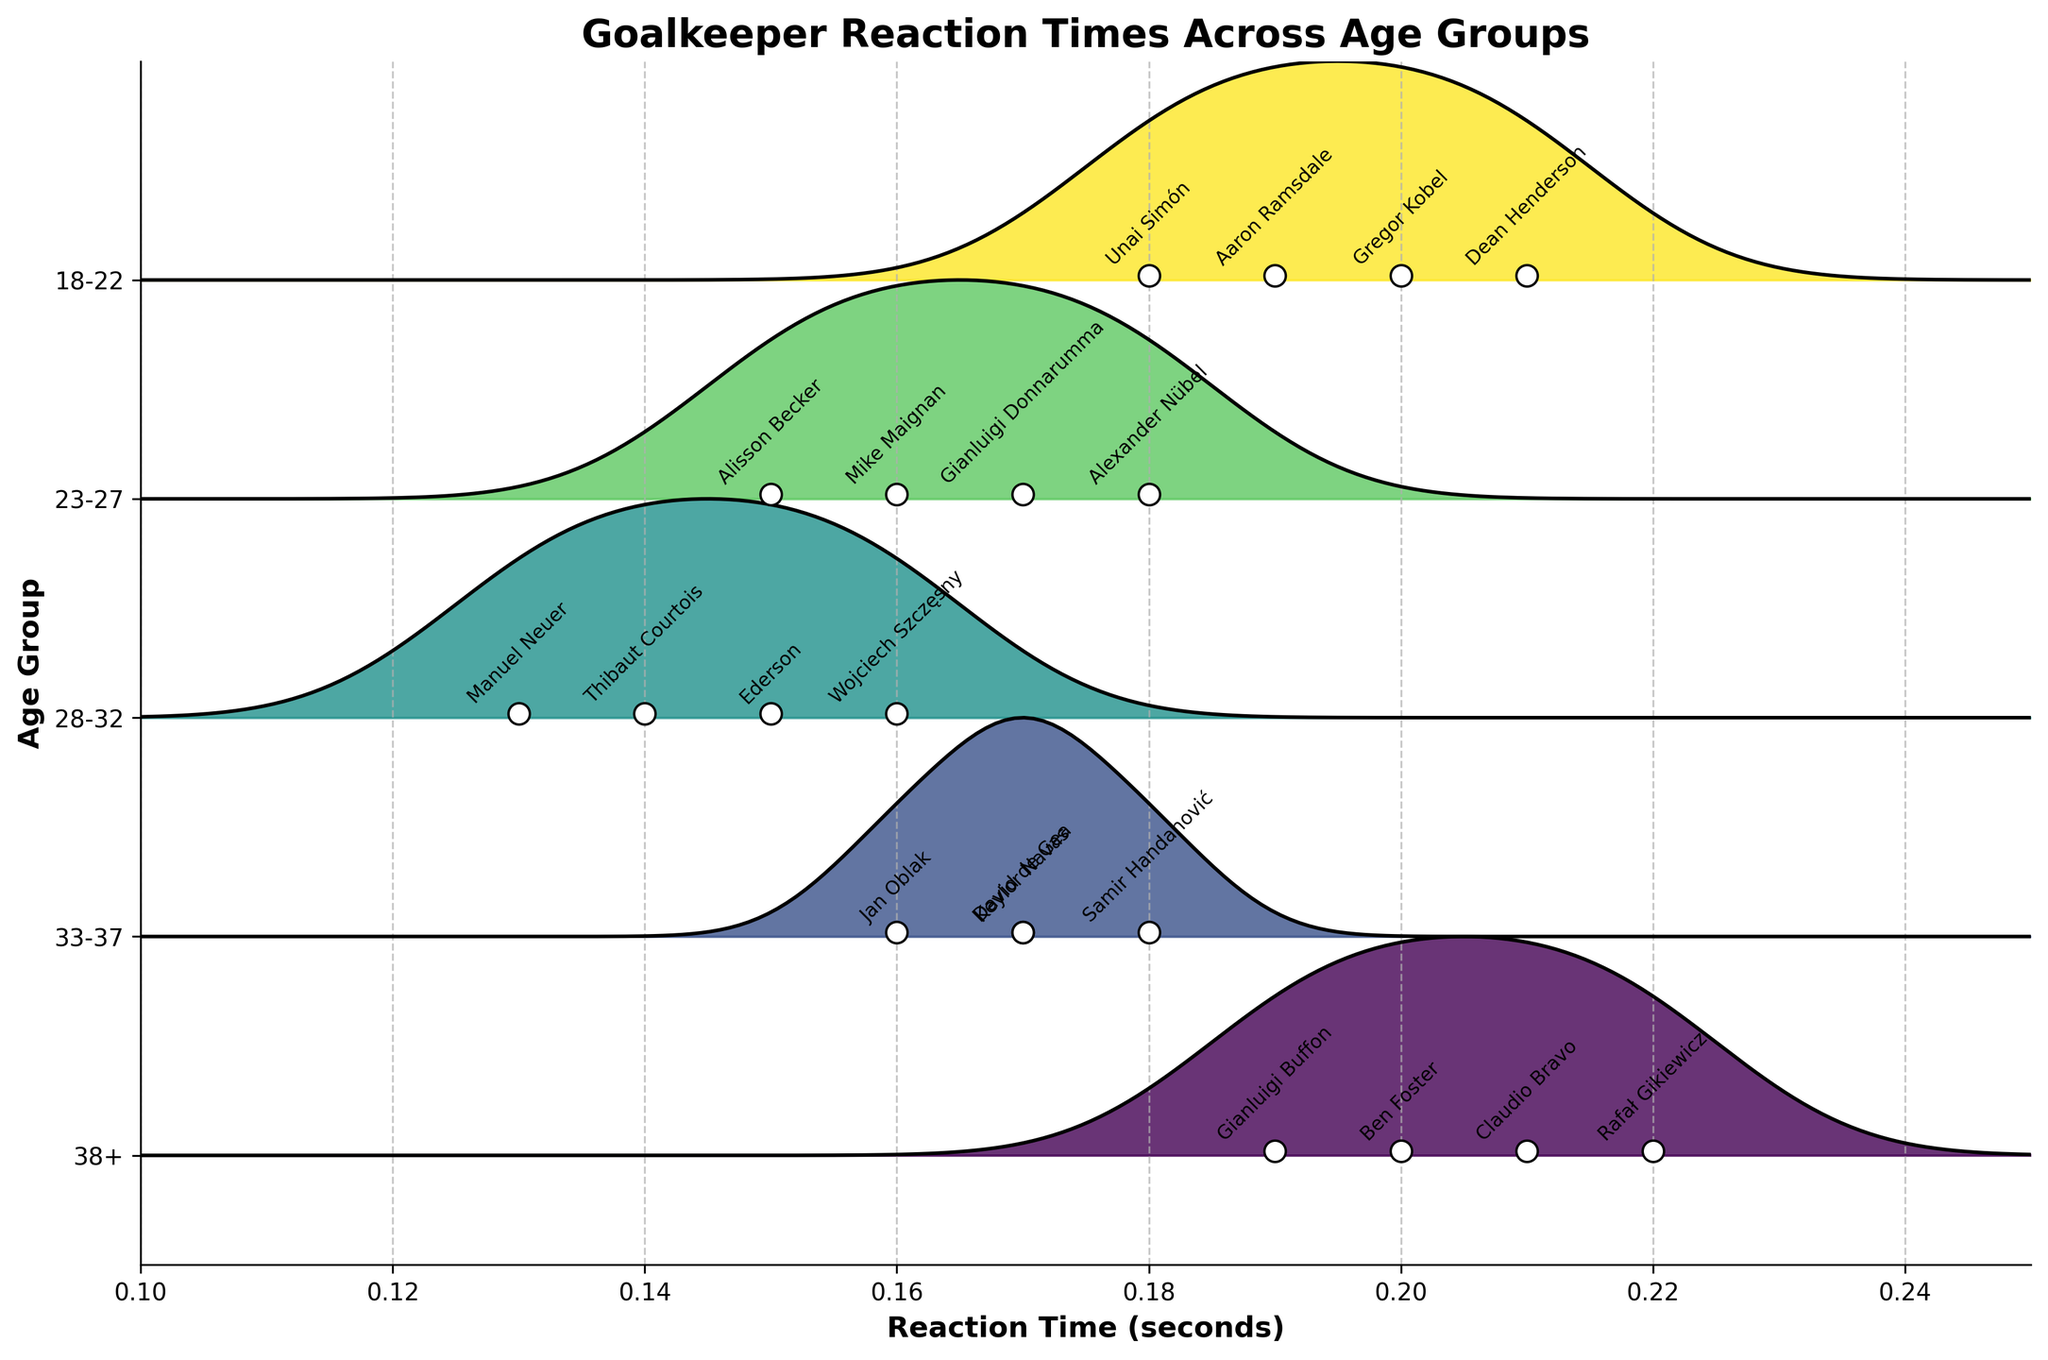What is the title of the plot? The title is prominently displayed at the top of the figure, summarizing the main context of the visualization.
Answer: Goalkeeper Reaction Times Across Age Groups Which age group has the best (lowest) average reaction time? By looking at the peaks of the ridgeline plots, the age group with the lowest position on the x-axis represents the best average reaction time.
Answer: 28-32 What are the reaction times of goalkeepers in the 38+ age group? The reaction times for the goalkeepers in this age group can be identified by the scatter points along the ridgeline plot.
Answer: 0.19, 0.20, 0.21, 0.22 How do the reaction times of goalkeepers in the 23-27 age group compare to those in the 18-22 age group? By comparing the positions of the peaks and individual points in both ridgelines, we can see which age group generally has higher or lower reaction times.
Answer: 23-27 has better (lower) reaction times overall Which goalkeeper has the fastest reaction time in the 18-22 age group and what is it? Each goalkeeper's reaction time is labeled on the scatter points. Find the lowest point in the 18-22 group.
Answer: Unai Simón, 0.18 Which goalkeeper has the slowest reaction time across all age groups and what is it? Identify the point farthest to the right (highest reaction time) across all ridgeline plots.
Answer: Rafał Gikiewicz, 0.22 How many goalkeepers in the 33-37 age group have a reaction time of 0.17 seconds? Look for scatter points in the 33-37 group aligned with the 0.17 seconds mark on the x-axis.
Answer: Two (David de Gea, Keylor Navas) What is the range of the reaction times for the 28-32 age group? Find the lowest and highest points in the 28-32 ridge and subtract the lowest value from the highest value.
Answer: 0.13 to 0.16 Compare the concentration of reaction times between the 18-22 and the 33-37 age groups. Analyze the width and height of the ridgelines to determine how spread out the reaction times are for these age groups.
Answer: 18-22 is more spread out than 33-37 Who has a better reaction time, Alisson Becker or David de Gea, and by how much? Compare their reaction times directly by locating their points on the plot. Subtract the reaction time of Alisson Becker from that of David de Gea.
Answer: Alisson Becker, by 0.02 seconds 